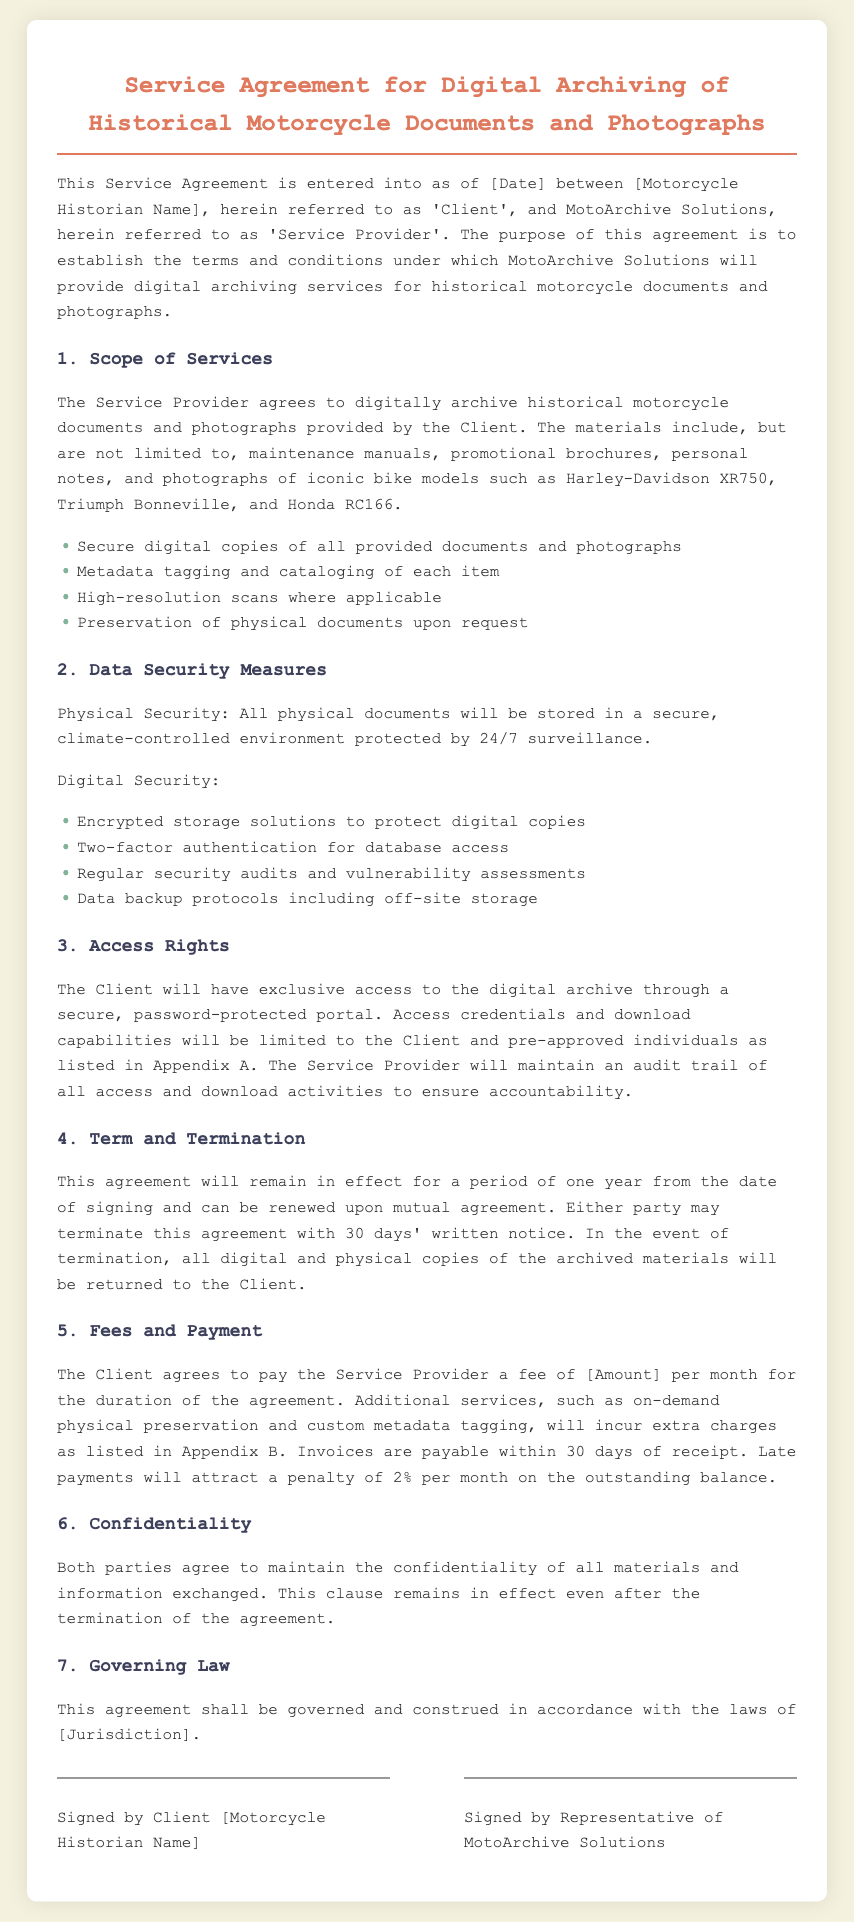What is the name of the Service Provider? The Service Provider is referred to as MotoArchive Solutions in the document.
Answer: MotoArchive Solutions What types of materials are included in the scope of services? The materials to be archived include maintenance manuals, promotional brochures, personal notes, and photographs of iconic bike models.
Answer: Maintenance manuals, promotional brochures, personal notes, photographs What is the duration of the agreement? The agreement is to remain in effect for a period of one year from the date of signing.
Answer: One year What security measure is implemented for database access? The document mentions two-factor authentication as a security measure for accessing the database.
Answer: Two-factor authentication How much is the monthly fee for the service? The amount for the monthly fee is to be determined, as it is represented by a placeholder in the document.
Answer: [Amount] 